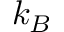<formula> <loc_0><loc_0><loc_500><loc_500>k _ { B }</formula> 